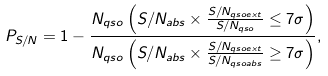<formula> <loc_0><loc_0><loc_500><loc_500>P _ { S / N } = 1 - \frac { N _ { q s o } \left ( S / N _ { a b s } \times \frac { S / N _ { q s o e x t } } { S / N _ { q s o } } \leq 7 \sigma \right ) } { N _ { q s o } \left ( S / N _ { a b s } \times \frac { S / N _ { q s o e x t } } { S / N _ { q s o a b s } } \geq 7 \sigma \right ) } ,</formula> 